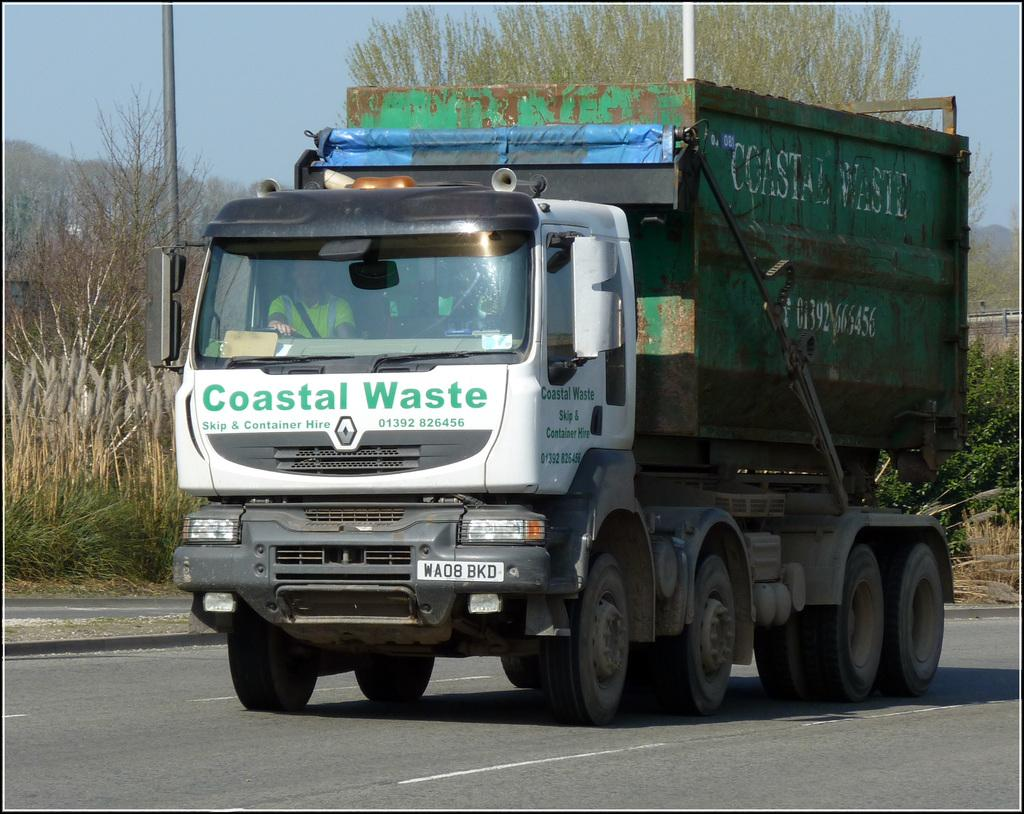What is the main subject of the image? The main subject of the image is a truck. What colors can be seen on the truck? The truck is white, green, blue, and black in color. Where is the truck located in the image? The truck is on the road. What can be seen in the background of the image? There are trees, a metal pole, and the sky visible in the background of the image. What type of straw is being used by the manager in the image? There is no manager or straw present in the image. 